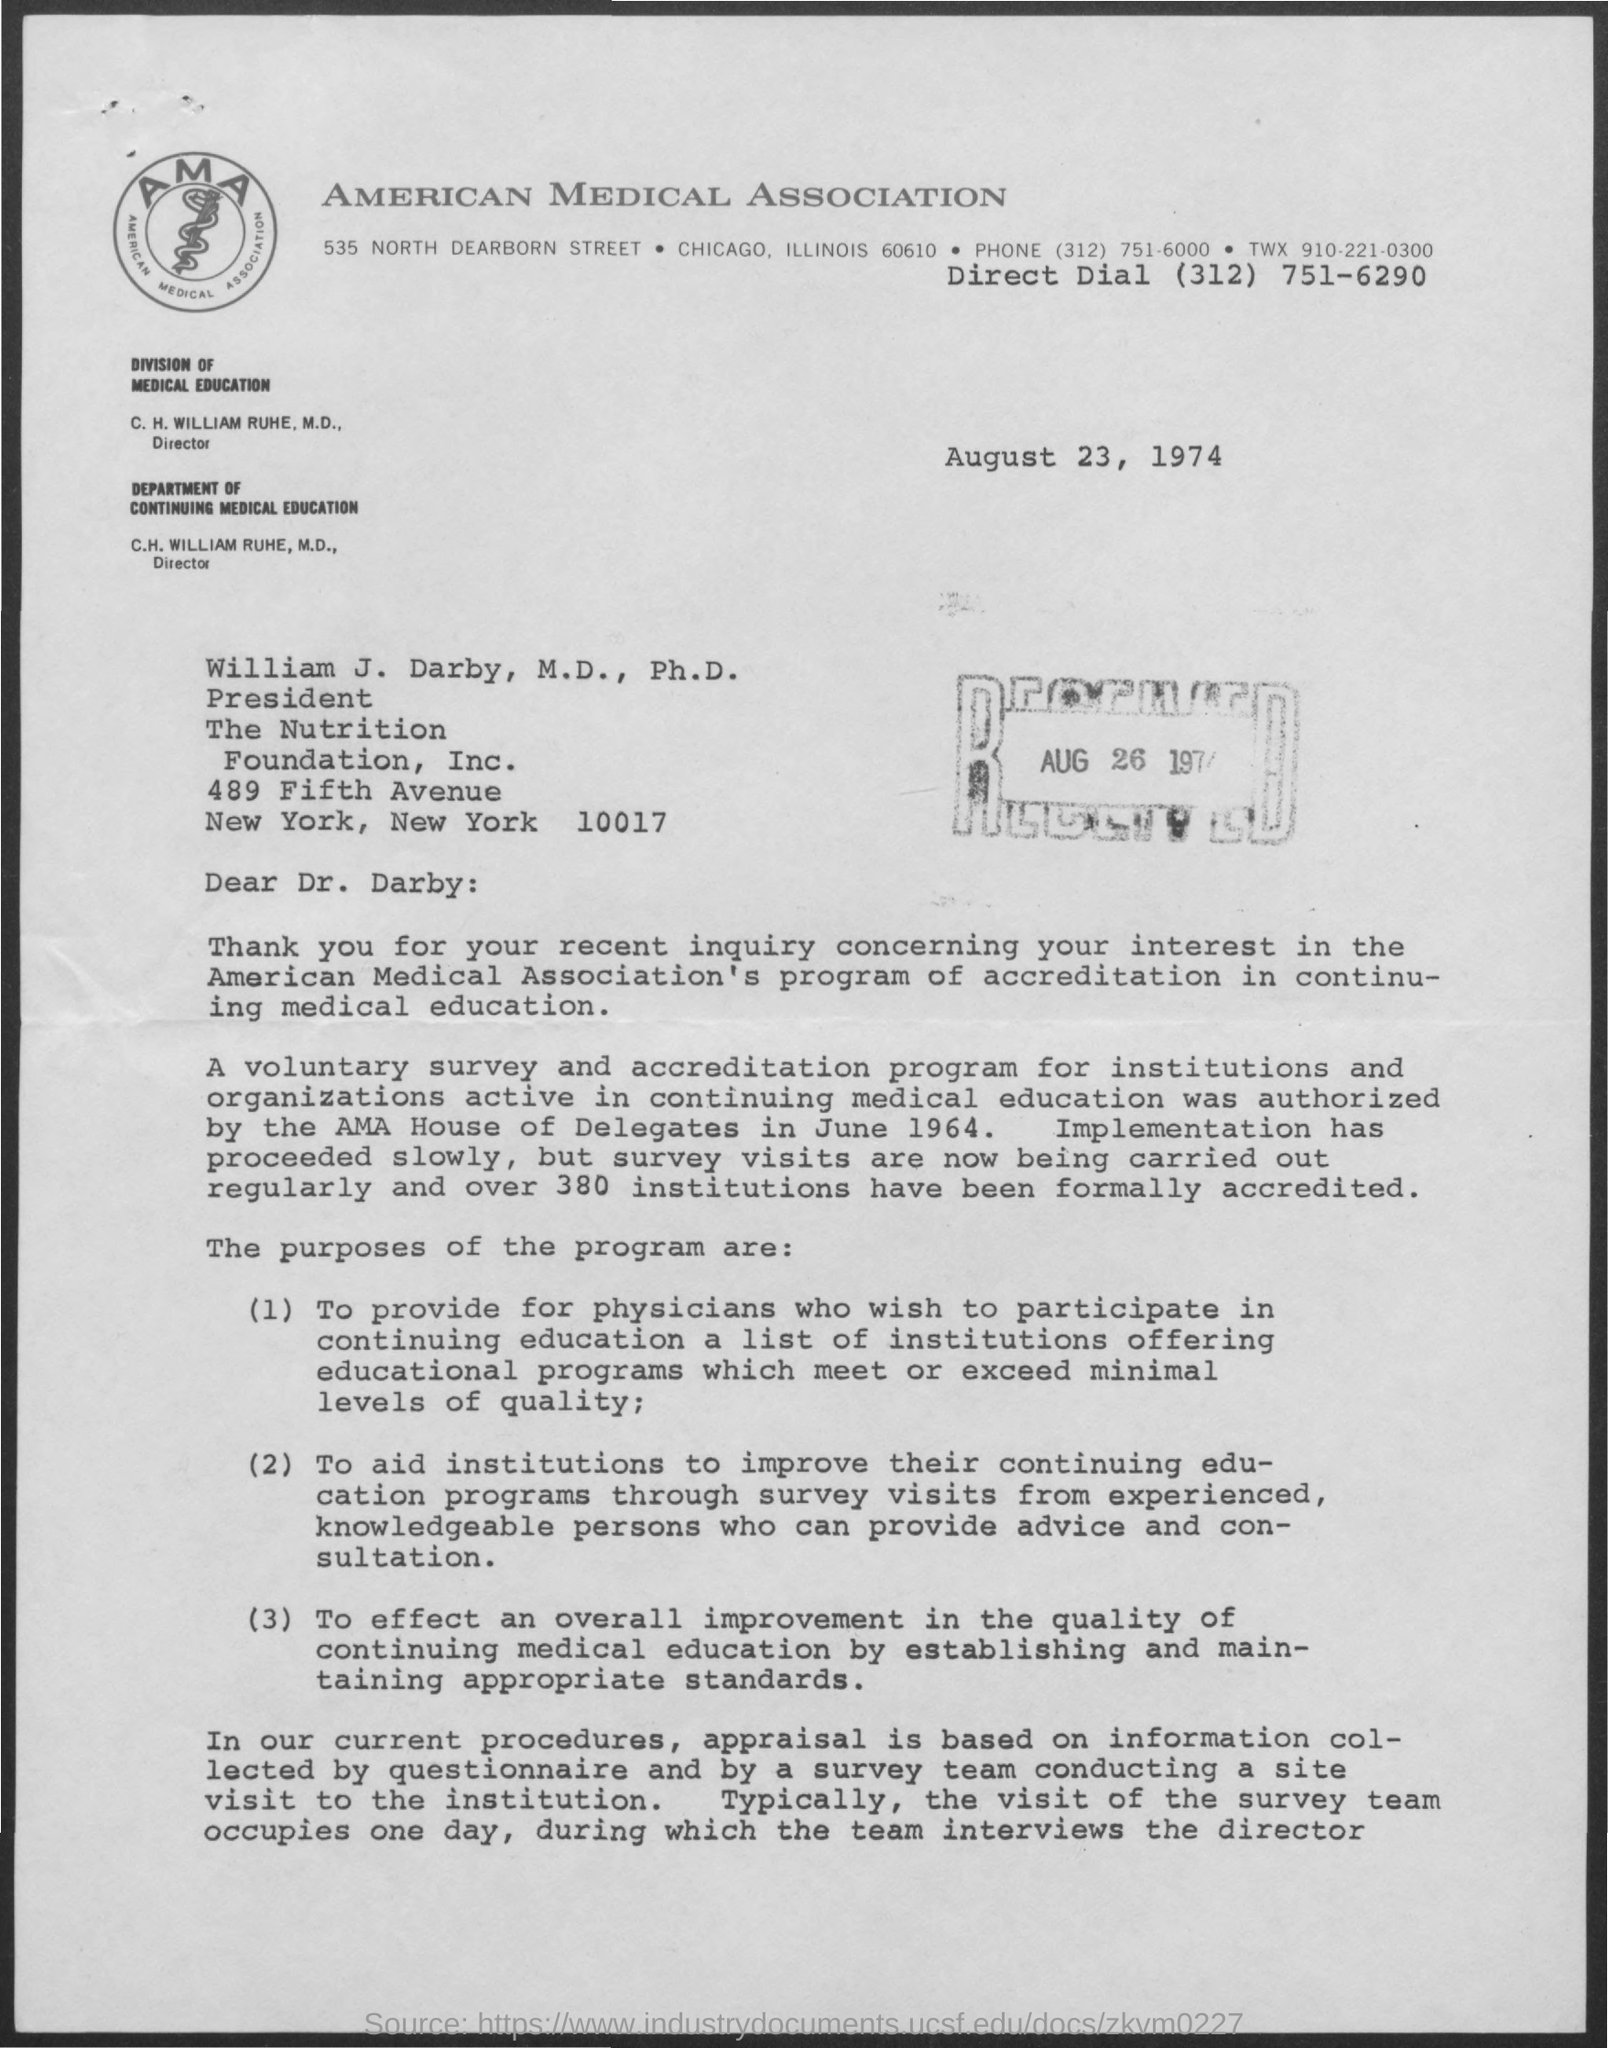Specify some key components in this picture. Over 380 institutes were accredited. The survey team will take one day to complete the survey. The House of Delegates authorized the program. The program was started in June 1964. 